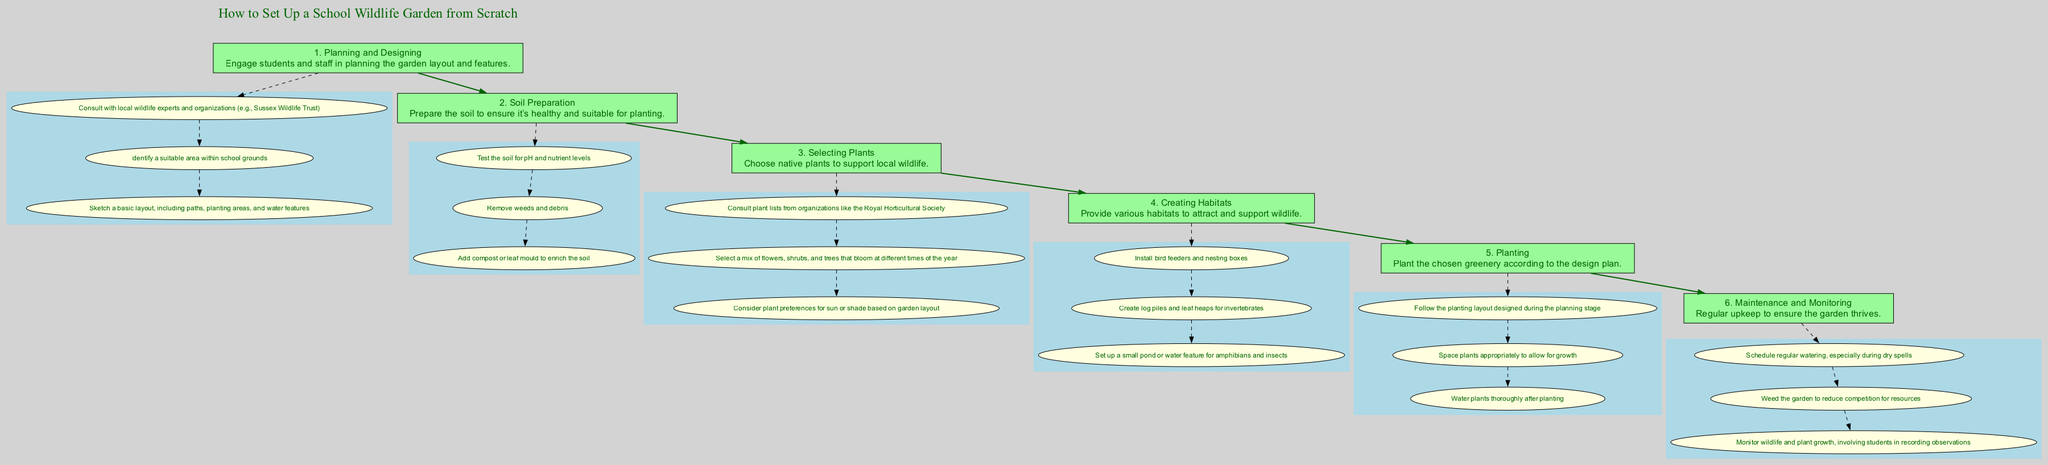What is the title of the diagram? The title is clearly presented at the top of the diagram, stating "How to Set Up a School Wildlife Garden from Scratch."
Answer: How to Set Up a School Wildlife Garden from Scratch How many main steps are shown in the diagram? By counting the main steps indicated within rectangles, there are a total of six steps listed in the flow chart.
Answer: 6 What is the second step in the process? The second step is labeled "Soil Preparation," which follows after "Planning and Designing."
Answer: Soil Preparation Which organization should be consulted according to the first step? The diagram specifies consulting "local wildlife experts and organizations (e.g., Sussex Wildlife Trust)" as part of the planning process.
Answer: Sussex Wildlife Trust What is the last action listed under the "Maintenance and Monitoring" step? The last action in this section is to "Monitor wildlife and plant growth, involving students in recording observations," as shown in the sub-nodes of the sixth step.
Answer: Monitor wildlife and plant growth, involving students in recording observations How do the main steps connect to each other? The main steps in the diagram are connected by directed edges, which indicate the flow of the process from one step to the next, illustrating a linear progression.
Answer: Directed edges What type of plants should be selected in step three? The diagram mentions selecting "native plants" as an essential consideration for supporting local wildlife in the "Selecting Plants" step.
Answer: Native plants Which feature is included in the "Creating Habitats" step for amphibians? A small pond or water feature is specifically mentioned as a habitat to attract and support amphibians in this step.
Answer: Small pond or water feature How many actions are associated with the "Selecting Plants" step? There are three actions listed under the "Selecting Plants" step, which include consulting plant lists, selecting a variety mix, and considering plant light preferences.
Answer: 3 